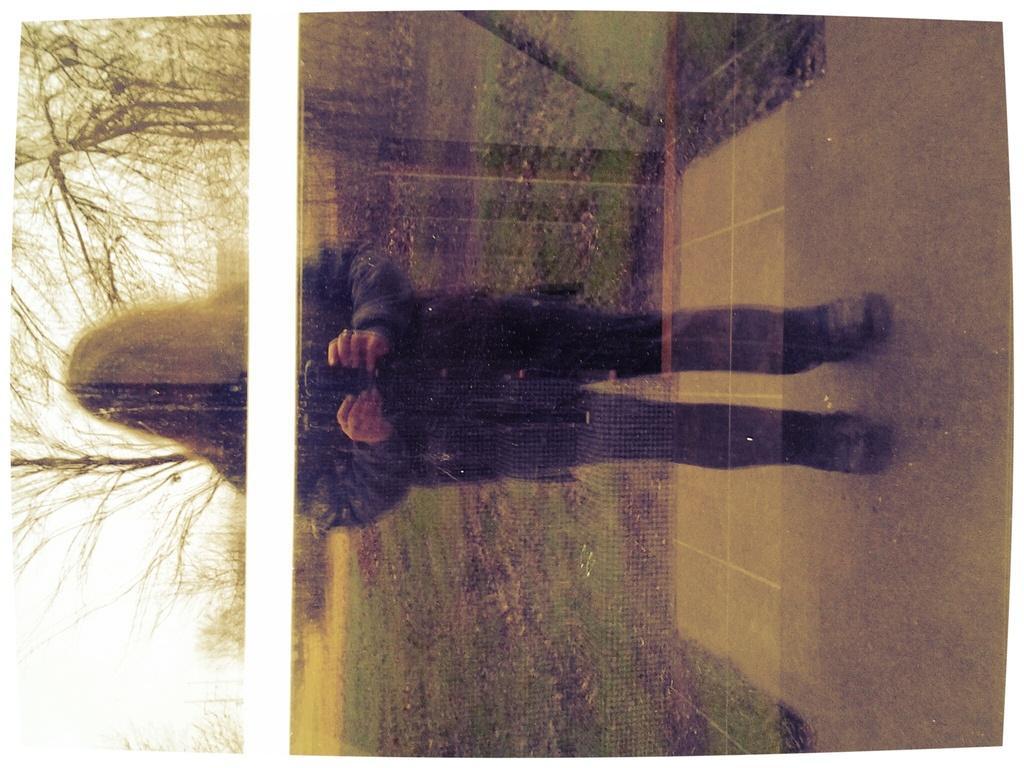Could you give a brief overview of what you see in this image? This is a tilted image, in this image there is a lady standing, in the background there are trees and it is blurred. 